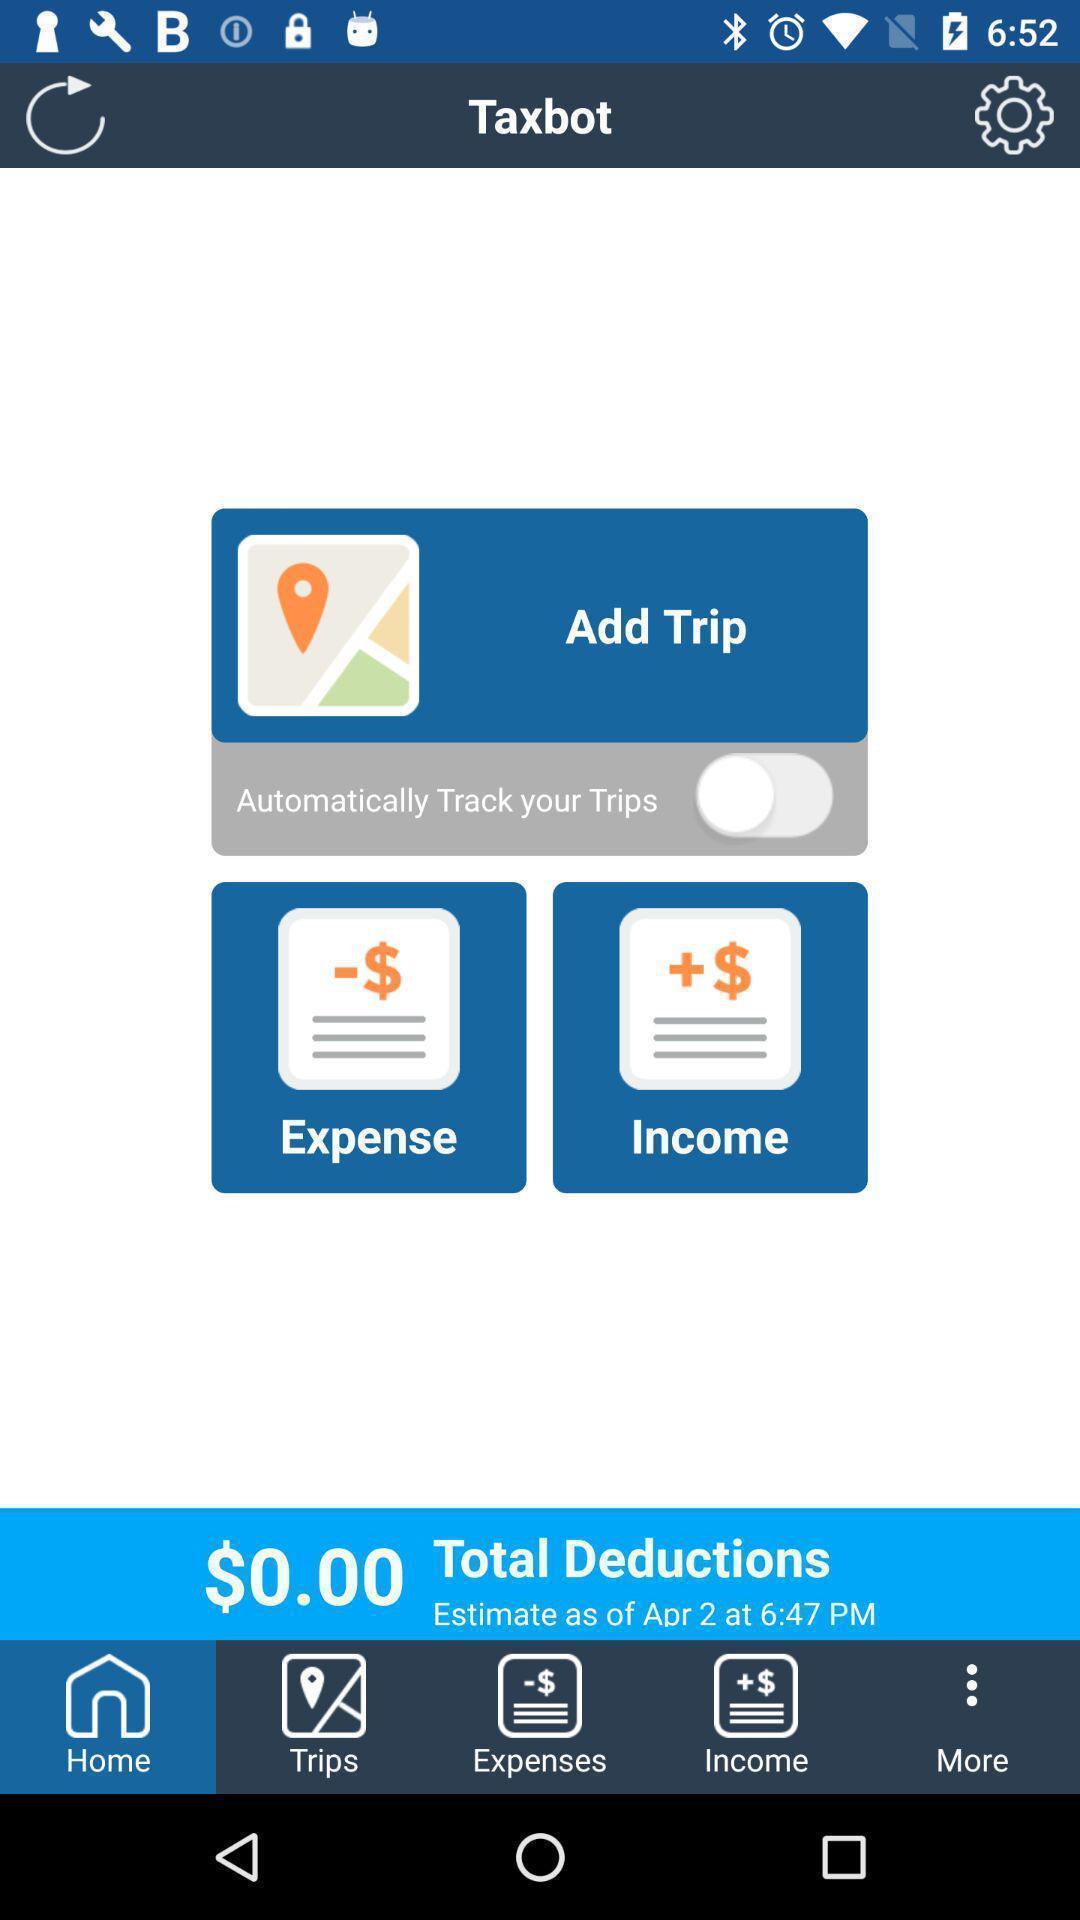Give me a narrative description of this picture. Page displaying different options. 